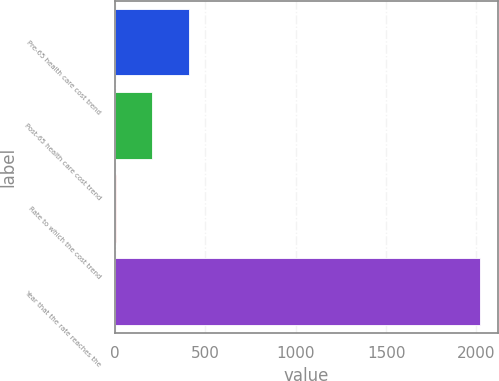Convert chart. <chart><loc_0><loc_0><loc_500><loc_500><bar_chart><fcel>Pre-65 health care cost trend<fcel>Post-65 health care cost trend<fcel>Rate to which the cost trend<fcel>Year that the rate reaches the<nl><fcel>407.6<fcel>206.3<fcel>5<fcel>2018<nl></chart> 